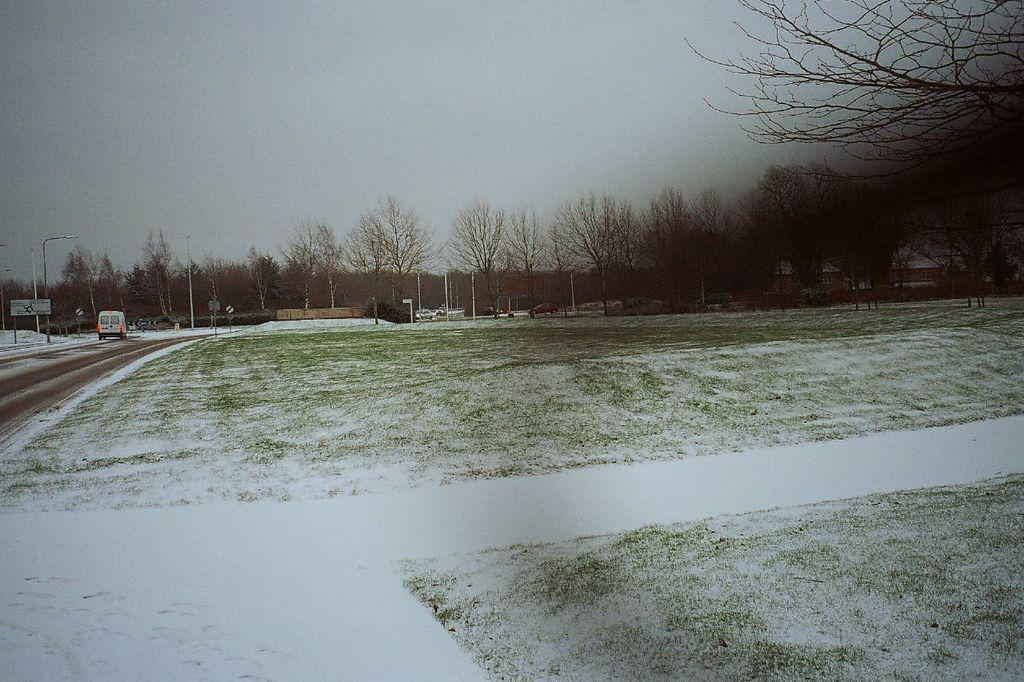What is the condition of the ground in the image? The place in the image is covered with snow. What atmospheric condition can be observed in the image? There is fog in the image. What type of transportation is visible on the road? There are vehicles on the road in the image. What type of natural vegetation is present in the image? There are trees in the image. What hobbies do the trees in the image enjoy? Trees do not have hobbies, as they are inanimate objects. 